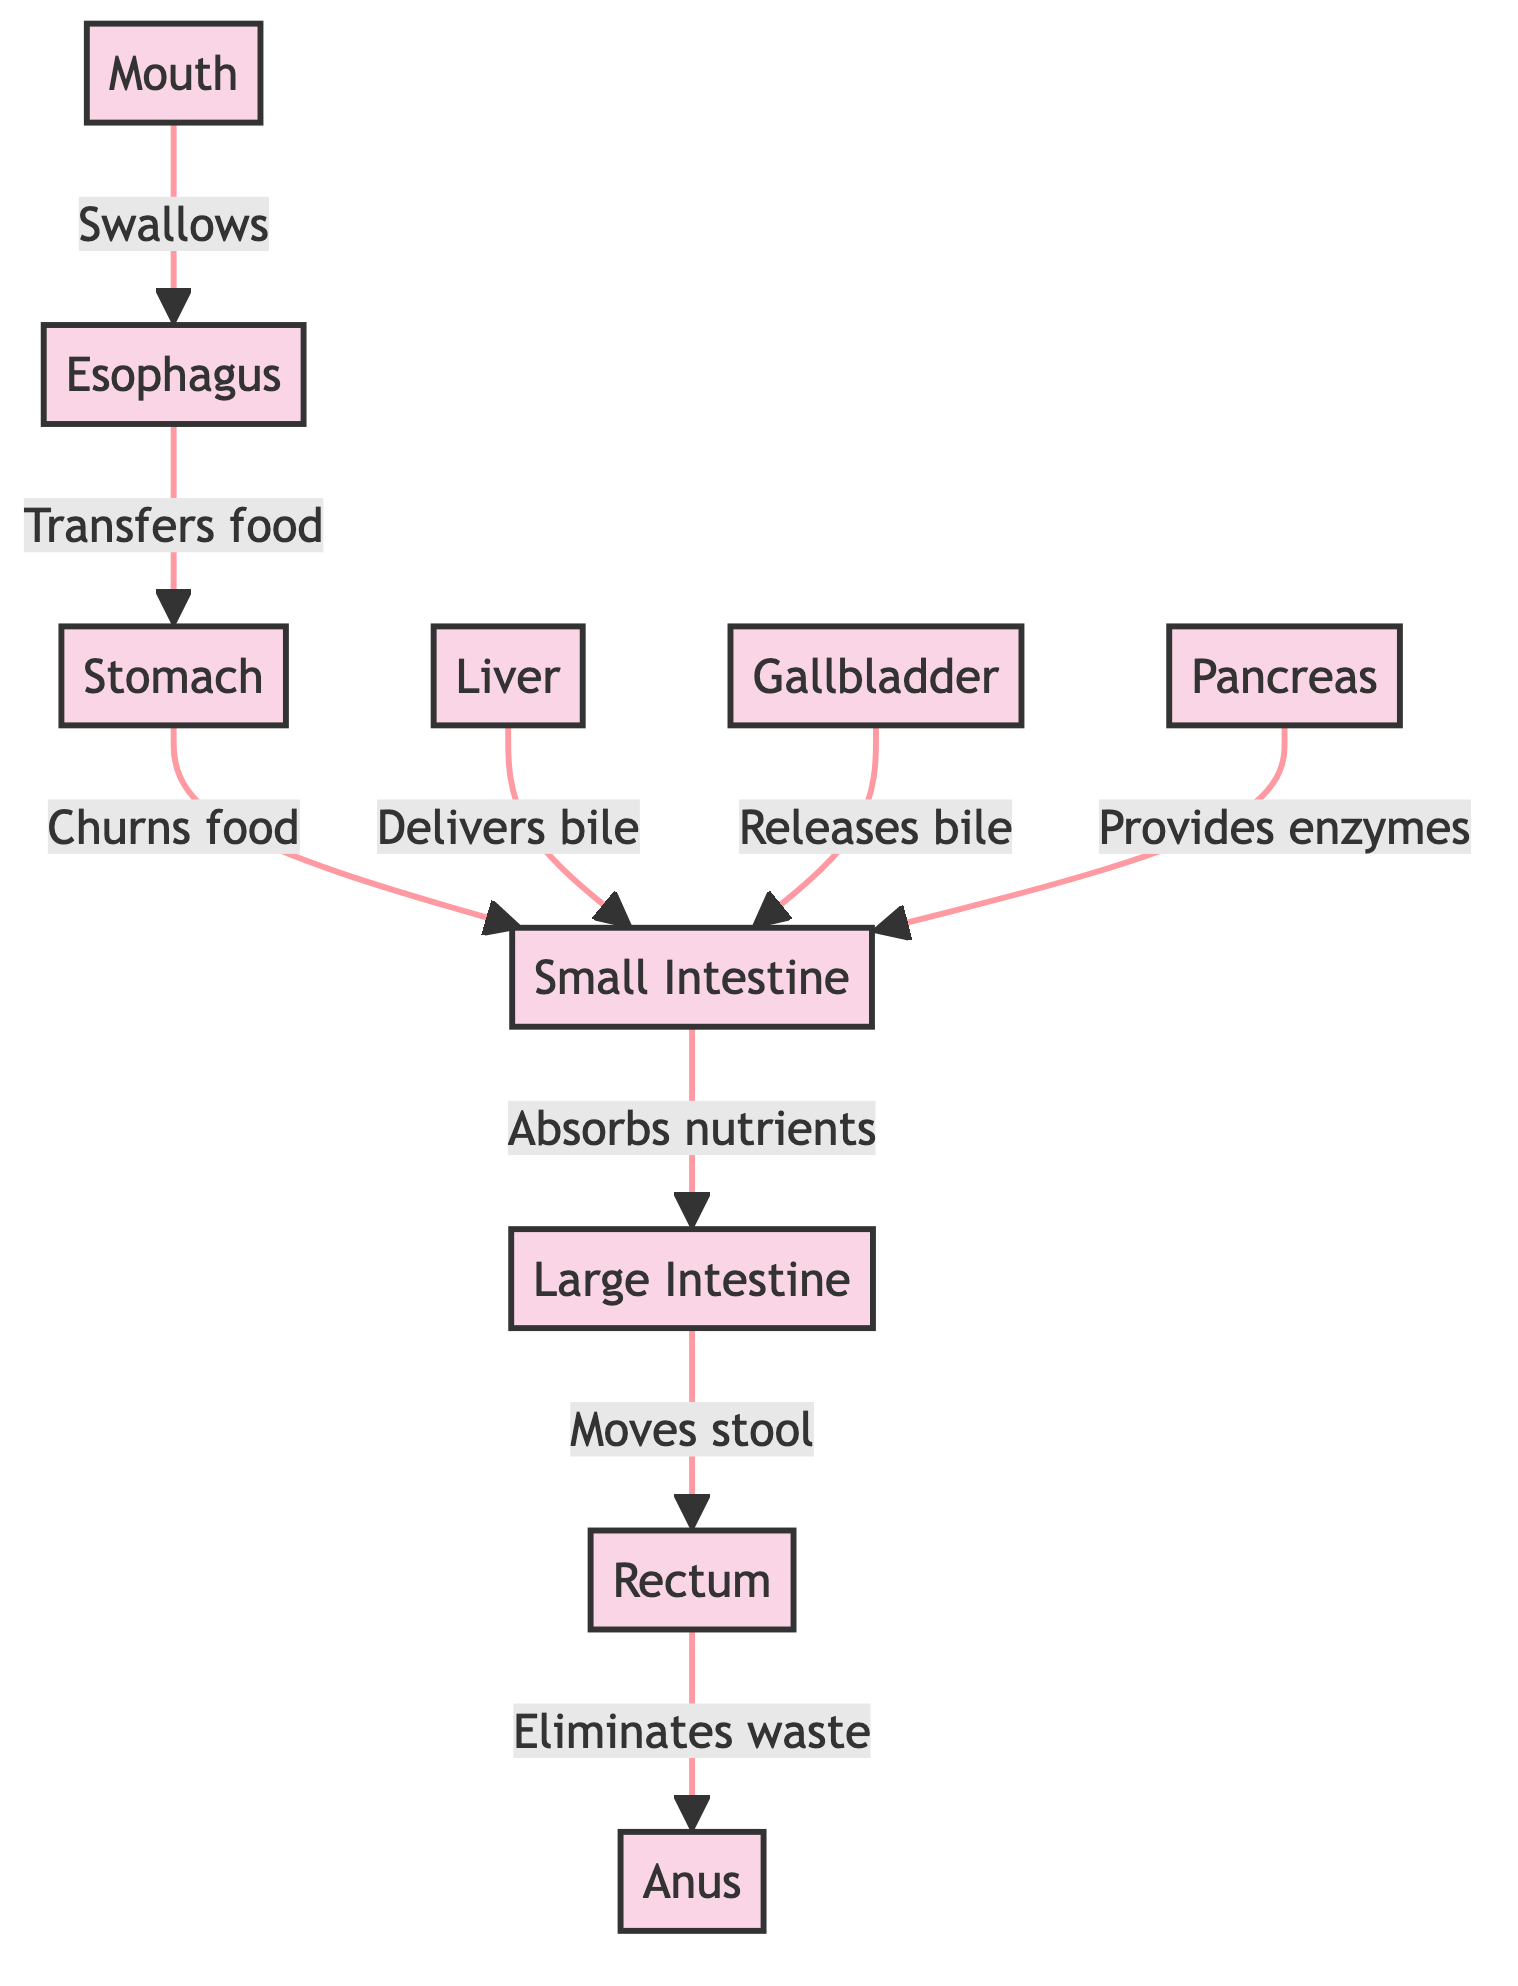What is the first organ in the digestive system? The first organ in the diagram is the mouth, which begins the digestive process by swallowing food.
Answer: Mouth How many organs are represented in the diagram? There are 10 organs shown in the diagram: mouth, esophagus, stomach, liver, gallbladder, pancreas, small intestine, large intestine, rectum, and anus.
Answer: 10 What process occurs in the stomach? In the stomach, the process described is "Churns food," indicating the role of the stomach in mechanical digestion.
Answer: Churns food What organ delivers bile to the small intestine? The liver is the organ that delivers bile to the small intestine, which aids in digestion.
Answer: Liver Which organ absorbs nutrients? The small intestine is responsible for absorbing nutrients from the digested food before it moves to the large intestine.
Answer: Small Intestine What sequence occurs after food leaves the esophagus? After food leaves the esophagus, it goes to the stomach as the next step in the digestive process.
Answer: Stomach Which organ provides enzymes to the small intestine? The pancreas provides enzymes to the small intestine, facilitating the breakdown of food for nutrient absorption.
Answer: Pancreas What is the final step in the digestive process depicted in the diagram? The final step is the elimination of waste from the body, which occurs at the anus.
Answer: Anus How does bile reach the small intestine from the gallbladder? Bile is released from the gallbladder into the small intestine, assisting in the digestion of fats.
Answer: Releases bile What organ follows the large intestine in the digestive process? The rectum follows the large intestine, which collects and stores waste before elimination.
Answer: Rectum 